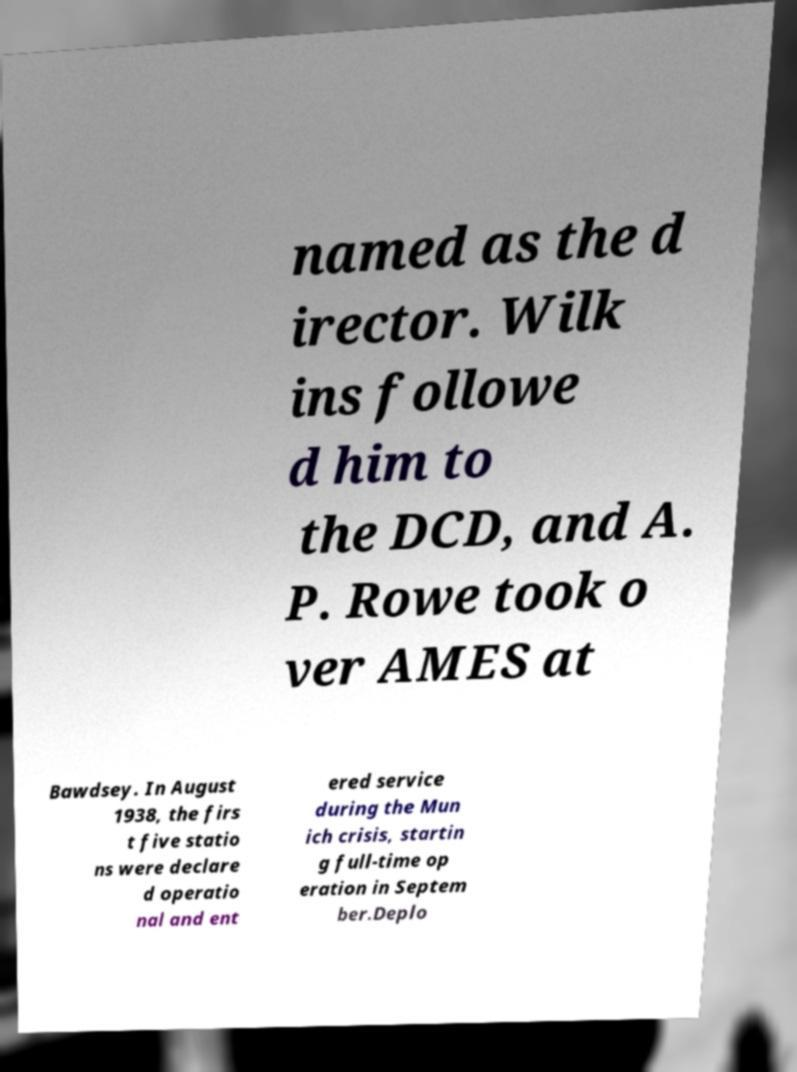What messages or text are displayed in this image? I need them in a readable, typed format. named as the d irector. Wilk ins followe d him to the DCD, and A. P. Rowe took o ver AMES at Bawdsey. In August 1938, the firs t five statio ns were declare d operatio nal and ent ered service during the Mun ich crisis, startin g full-time op eration in Septem ber.Deplo 